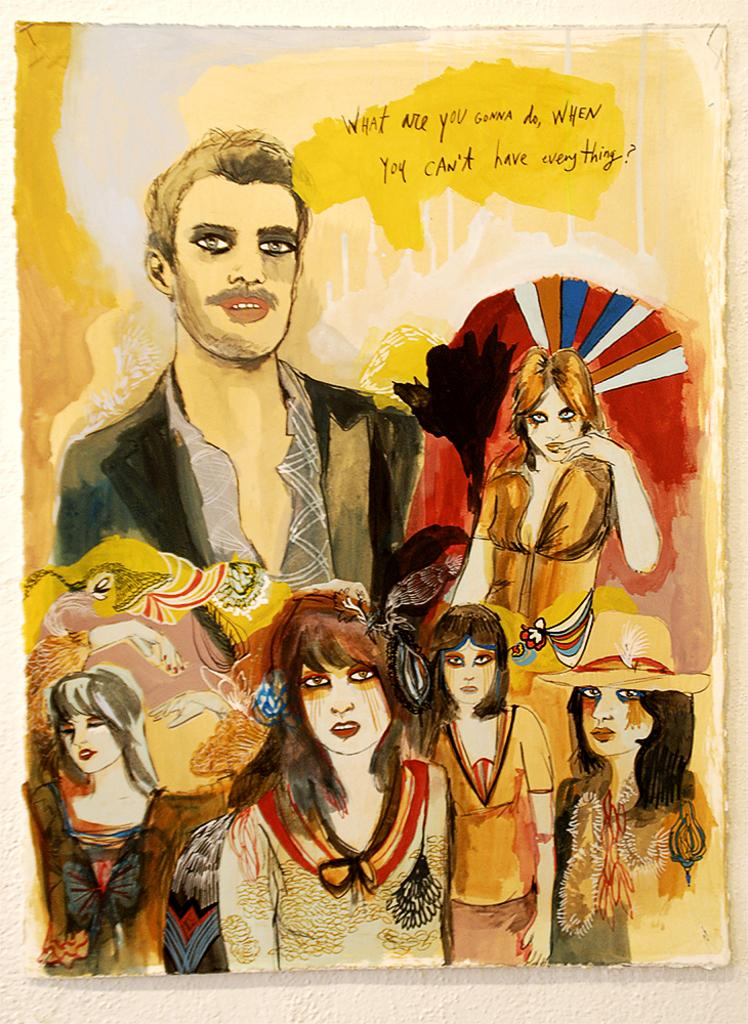What is featured in the image? There is a poster in the image. What can be seen on the poster? The poster contains people. What are the people in the poster wearing? The people in the poster are wearing costumes. What type of gold veil can be seen on the people in the image? There is no gold veil present in the image; the people in the poster are wearing costumes, but no specific details about the costumes are provided. 